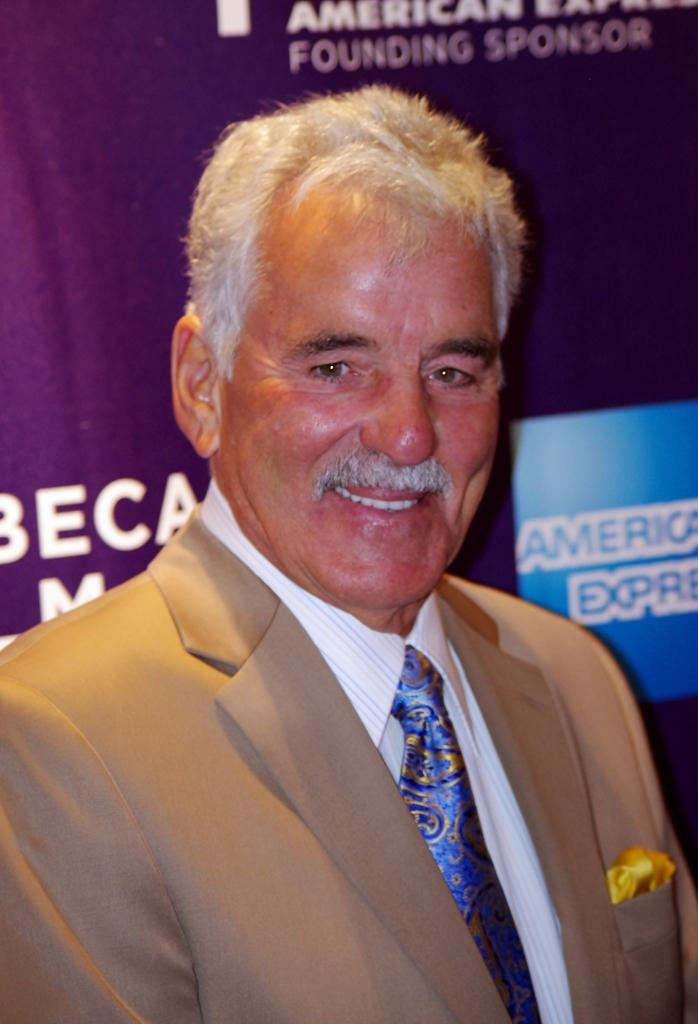What is the main subject of the image? The main subject of the image is a man. What is the man doing in the image? The man is standing in the image. What is the man wearing in the image? The man is wearing a suit in the image. What type of fuel is the man using to power his car in the image? There is no car present in the image, and therefore no fuel can be associated with the man. 